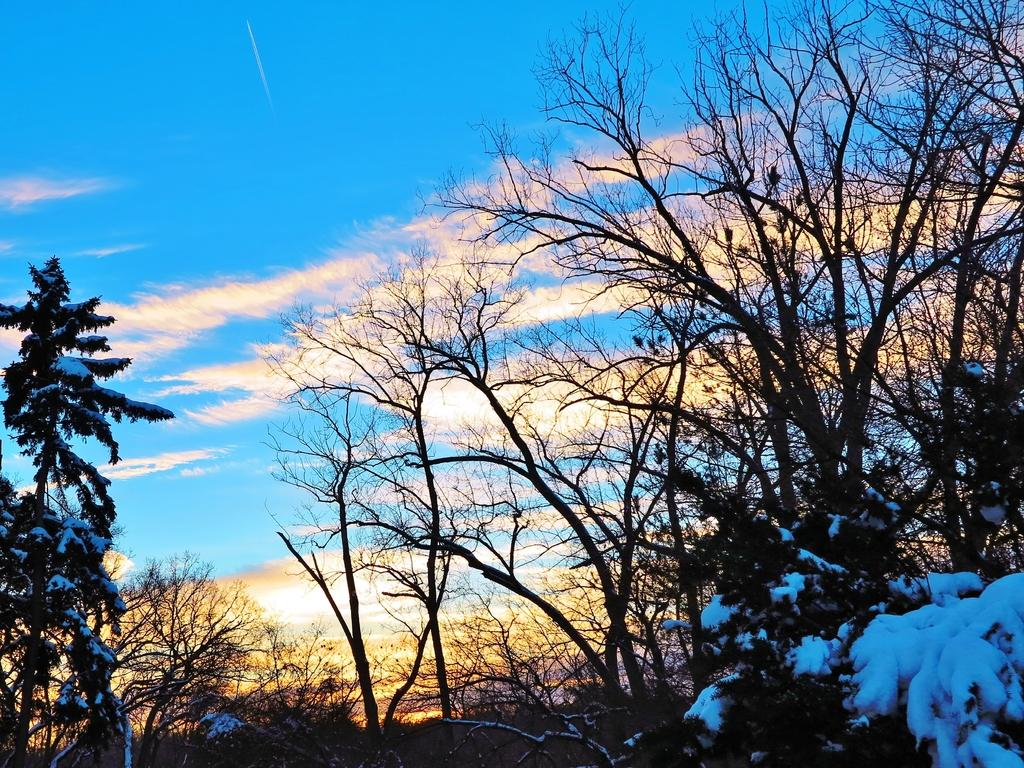What type of vegetation can be seen in the image? There are trees in the image. What is covering the trees in the image? Snow is present on the trees. What can be seen in the background of the image? There are clouds and a blue sky in the background of the image. What type of industry is depicted in the image? There is no industry present in the image; it features trees covered in snow with a blue sky and clouds in the background. 